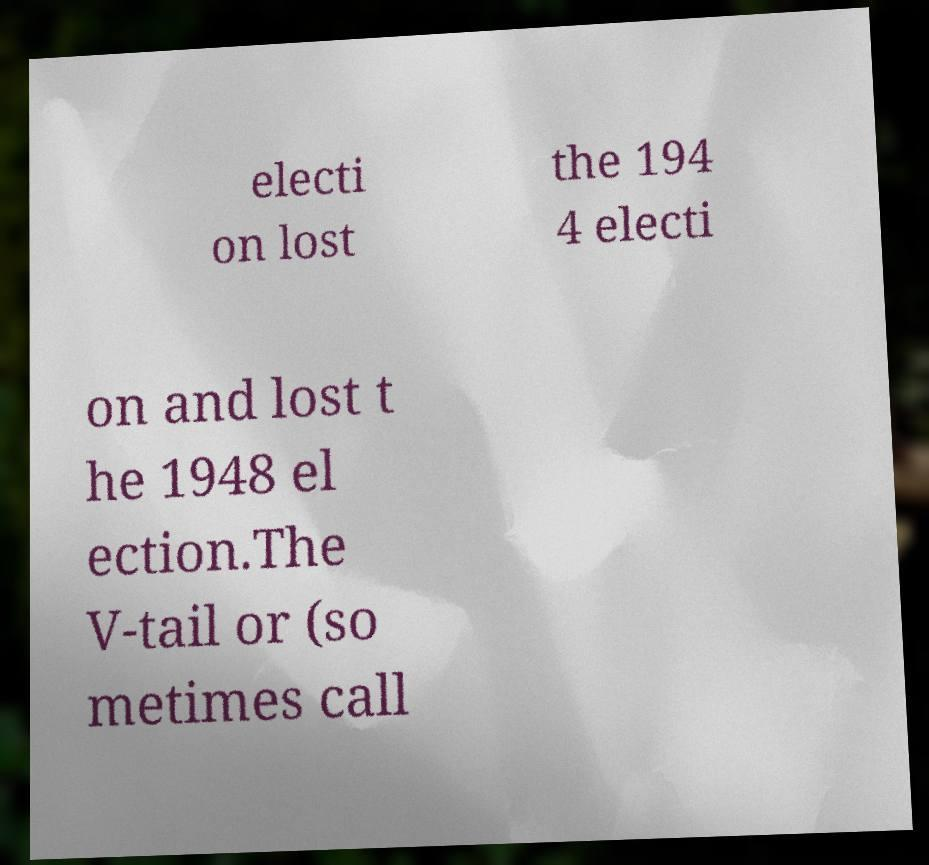What messages or text are displayed in this image? I need them in a readable, typed format. electi on lost the 194 4 electi on and lost t he 1948 el ection.The V-tail or (so metimes call 